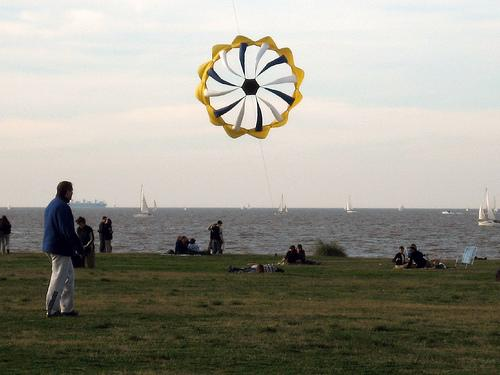The item in the sky looks most like what? Please explain your reasoning. wheel. The item in the sky is round. it has spokes. 